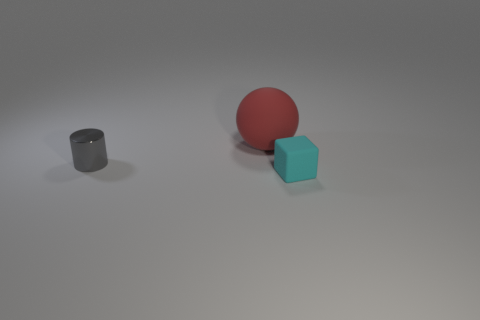Subtract 0 brown spheres. How many objects are left? 3 Subtract all cubes. How many objects are left? 2 Subtract all green cylinders. Subtract all blue balls. How many cylinders are left? 1 Subtract all cyan cubes. How many yellow cylinders are left? 0 Subtract all big red balls. Subtract all red objects. How many objects are left? 1 Add 3 tiny rubber blocks. How many tiny rubber blocks are left? 4 Add 1 large objects. How many large objects exist? 2 Add 3 small yellow things. How many objects exist? 6 